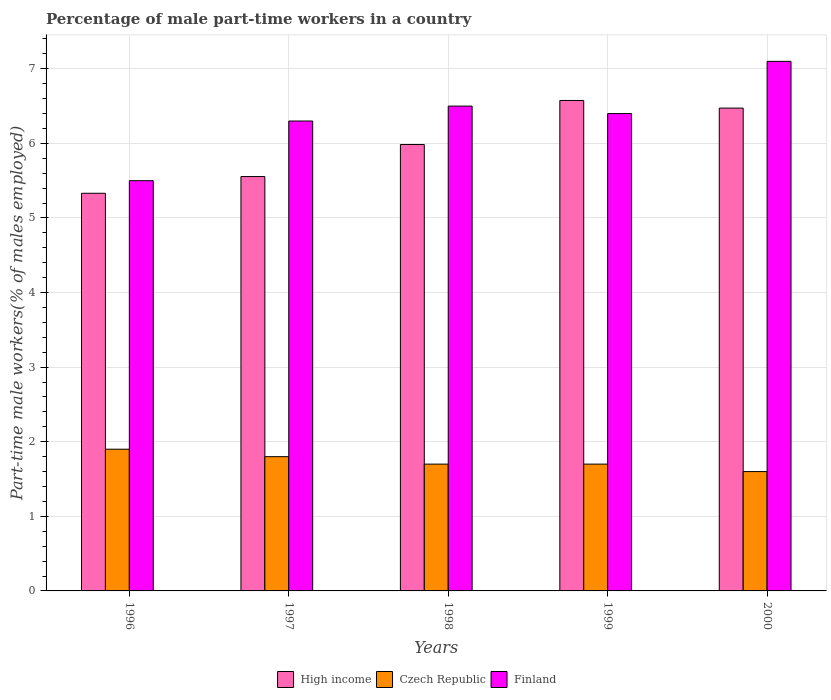Are the number of bars per tick equal to the number of legend labels?
Make the answer very short. Yes. Are the number of bars on each tick of the X-axis equal?
Your answer should be compact. Yes. How many bars are there on the 4th tick from the left?
Provide a succinct answer. 3. How many bars are there on the 5th tick from the right?
Give a very brief answer. 3. What is the label of the 1st group of bars from the left?
Your answer should be very brief. 1996. Across all years, what is the maximum percentage of male part-time workers in High income?
Offer a very short reply. 6.58. Across all years, what is the minimum percentage of male part-time workers in Czech Republic?
Provide a succinct answer. 1.6. In which year was the percentage of male part-time workers in Czech Republic minimum?
Keep it short and to the point. 2000. What is the total percentage of male part-time workers in Czech Republic in the graph?
Provide a short and direct response. 8.7. What is the difference between the percentage of male part-time workers in High income in 1998 and that in 1999?
Offer a terse response. -0.59. What is the difference between the percentage of male part-time workers in High income in 2000 and the percentage of male part-time workers in Finland in 1996?
Ensure brevity in your answer.  0.97. What is the average percentage of male part-time workers in Czech Republic per year?
Ensure brevity in your answer.  1.74. In the year 1996, what is the difference between the percentage of male part-time workers in Czech Republic and percentage of male part-time workers in Finland?
Provide a short and direct response. -3.6. What is the ratio of the percentage of male part-time workers in High income in 1998 to that in 2000?
Provide a short and direct response. 0.92. Is the percentage of male part-time workers in Czech Republic in 1996 less than that in 1997?
Your response must be concise. No. Is the difference between the percentage of male part-time workers in Czech Republic in 1997 and 1999 greater than the difference between the percentage of male part-time workers in Finland in 1997 and 1999?
Your answer should be very brief. Yes. What is the difference between the highest and the second highest percentage of male part-time workers in Czech Republic?
Provide a short and direct response. 0.1. What is the difference between the highest and the lowest percentage of male part-time workers in Czech Republic?
Ensure brevity in your answer.  0.3. In how many years, is the percentage of male part-time workers in Czech Republic greater than the average percentage of male part-time workers in Czech Republic taken over all years?
Provide a succinct answer. 2. Is the sum of the percentage of male part-time workers in High income in 1998 and 2000 greater than the maximum percentage of male part-time workers in Czech Republic across all years?
Give a very brief answer. Yes. What does the 2nd bar from the right in 2000 represents?
Make the answer very short. Czech Republic. How many bars are there?
Provide a short and direct response. 15. Are the values on the major ticks of Y-axis written in scientific E-notation?
Ensure brevity in your answer.  No. Where does the legend appear in the graph?
Offer a terse response. Bottom center. How many legend labels are there?
Your answer should be compact. 3. How are the legend labels stacked?
Make the answer very short. Horizontal. What is the title of the graph?
Your answer should be very brief. Percentage of male part-time workers in a country. What is the label or title of the X-axis?
Your response must be concise. Years. What is the label or title of the Y-axis?
Your answer should be compact. Part-time male workers(% of males employed). What is the Part-time male workers(% of males employed) of High income in 1996?
Provide a short and direct response. 5.33. What is the Part-time male workers(% of males employed) of Czech Republic in 1996?
Ensure brevity in your answer.  1.9. What is the Part-time male workers(% of males employed) of High income in 1997?
Give a very brief answer. 5.56. What is the Part-time male workers(% of males employed) of Czech Republic in 1997?
Offer a terse response. 1.8. What is the Part-time male workers(% of males employed) in Finland in 1997?
Make the answer very short. 6.3. What is the Part-time male workers(% of males employed) in High income in 1998?
Provide a succinct answer. 5.98. What is the Part-time male workers(% of males employed) in Czech Republic in 1998?
Give a very brief answer. 1.7. What is the Part-time male workers(% of males employed) in Finland in 1998?
Your answer should be very brief. 6.5. What is the Part-time male workers(% of males employed) of High income in 1999?
Offer a very short reply. 6.58. What is the Part-time male workers(% of males employed) of Czech Republic in 1999?
Ensure brevity in your answer.  1.7. What is the Part-time male workers(% of males employed) of Finland in 1999?
Offer a very short reply. 6.4. What is the Part-time male workers(% of males employed) of High income in 2000?
Provide a succinct answer. 6.47. What is the Part-time male workers(% of males employed) of Czech Republic in 2000?
Give a very brief answer. 1.6. What is the Part-time male workers(% of males employed) of Finland in 2000?
Ensure brevity in your answer.  7.1. Across all years, what is the maximum Part-time male workers(% of males employed) in High income?
Ensure brevity in your answer.  6.58. Across all years, what is the maximum Part-time male workers(% of males employed) of Czech Republic?
Your answer should be compact. 1.9. Across all years, what is the maximum Part-time male workers(% of males employed) in Finland?
Keep it short and to the point. 7.1. Across all years, what is the minimum Part-time male workers(% of males employed) in High income?
Your response must be concise. 5.33. Across all years, what is the minimum Part-time male workers(% of males employed) of Czech Republic?
Provide a short and direct response. 1.6. What is the total Part-time male workers(% of males employed) in High income in the graph?
Ensure brevity in your answer.  29.92. What is the total Part-time male workers(% of males employed) of Finland in the graph?
Ensure brevity in your answer.  31.8. What is the difference between the Part-time male workers(% of males employed) of High income in 1996 and that in 1997?
Your answer should be compact. -0.22. What is the difference between the Part-time male workers(% of males employed) in Finland in 1996 and that in 1997?
Make the answer very short. -0.8. What is the difference between the Part-time male workers(% of males employed) of High income in 1996 and that in 1998?
Your response must be concise. -0.65. What is the difference between the Part-time male workers(% of males employed) of High income in 1996 and that in 1999?
Provide a succinct answer. -1.24. What is the difference between the Part-time male workers(% of males employed) in High income in 1996 and that in 2000?
Provide a short and direct response. -1.14. What is the difference between the Part-time male workers(% of males employed) in Czech Republic in 1996 and that in 2000?
Give a very brief answer. 0.3. What is the difference between the Part-time male workers(% of males employed) of High income in 1997 and that in 1998?
Make the answer very short. -0.43. What is the difference between the Part-time male workers(% of males employed) in Czech Republic in 1997 and that in 1998?
Offer a terse response. 0.1. What is the difference between the Part-time male workers(% of males employed) of Finland in 1997 and that in 1998?
Your answer should be very brief. -0.2. What is the difference between the Part-time male workers(% of males employed) in High income in 1997 and that in 1999?
Keep it short and to the point. -1.02. What is the difference between the Part-time male workers(% of males employed) of Finland in 1997 and that in 1999?
Your response must be concise. -0.1. What is the difference between the Part-time male workers(% of males employed) in High income in 1997 and that in 2000?
Your answer should be compact. -0.92. What is the difference between the Part-time male workers(% of males employed) in Czech Republic in 1997 and that in 2000?
Your response must be concise. 0.2. What is the difference between the Part-time male workers(% of males employed) in Finland in 1997 and that in 2000?
Offer a very short reply. -0.8. What is the difference between the Part-time male workers(% of males employed) in High income in 1998 and that in 1999?
Your answer should be compact. -0.59. What is the difference between the Part-time male workers(% of males employed) in Czech Republic in 1998 and that in 1999?
Your response must be concise. 0. What is the difference between the Part-time male workers(% of males employed) in High income in 1998 and that in 2000?
Offer a very short reply. -0.49. What is the difference between the Part-time male workers(% of males employed) of Finland in 1998 and that in 2000?
Provide a succinct answer. -0.6. What is the difference between the Part-time male workers(% of males employed) in High income in 1999 and that in 2000?
Keep it short and to the point. 0.1. What is the difference between the Part-time male workers(% of males employed) in Czech Republic in 1999 and that in 2000?
Your answer should be very brief. 0.1. What is the difference between the Part-time male workers(% of males employed) in High income in 1996 and the Part-time male workers(% of males employed) in Czech Republic in 1997?
Provide a short and direct response. 3.53. What is the difference between the Part-time male workers(% of males employed) of High income in 1996 and the Part-time male workers(% of males employed) of Finland in 1997?
Ensure brevity in your answer.  -0.97. What is the difference between the Part-time male workers(% of males employed) in High income in 1996 and the Part-time male workers(% of males employed) in Czech Republic in 1998?
Offer a terse response. 3.63. What is the difference between the Part-time male workers(% of males employed) in High income in 1996 and the Part-time male workers(% of males employed) in Finland in 1998?
Give a very brief answer. -1.17. What is the difference between the Part-time male workers(% of males employed) in Czech Republic in 1996 and the Part-time male workers(% of males employed) in Finland in 1998?
Make the answer very short. -4.6. What is the difference between the Part-time male workers(% of males employed) in High income in 1996 and the Part-time male workers(% of males employed) in Czech Republic in 1999?
Make the answer very short. 3.63. What is the difference between the Part-time male workers(% of males employed) in High income in 1996 and the Part-time male workers(% of males employed) in Finland in 1999?
Your answer should be compact. -1.07. What is the difference between the Part-time male workers(% of males employed) in Czech Republic in 1996 and the Part-time male workers(% of males employed) in Finland in 1999?
Keep it short and to the point. -4.5. What is the difference between the Part-time male workers(% of males employed) of High income in 1996 and the Part-time male workers(% of males employed) of Czech Republic in 2000?
Provide a succinct answer. 3.73. What is the difference between the Part-time male workers(% of males employed) of High income in 1996 and the Part-time male workers(% of males employed) of Finland in 2000?
Keep it short and to the point. -1.77. What is the difference between the Part-time male workers(% of males employed) of Czech Republic in 1996 and the Part-time male workers(% of males employed) of Finland in 2000?
Make the answer very short. -5.2. What is the difference between the Part-time male workers(% of males employed) of High income in 1997 and the Part-time male workers(% of males employed) of Czech Republic in 1998?
Provide a short and direct response. 3.86. What is the difference between the Part-time male workers(% of males employed) of High income in 1997 and the Part-time male workers(% of males employed) of Finland in 1998?
Offer a terse response. -0.94. What is the difference between the Part-time male workers(% of males employed) of High income in 1997 and the Part-time male workers(% of males employed) of Czech Republic in 1999?
Your answer should be very brief. 3.86. What is the difference between the Part-time male workers(% of males employed) of High income in 1997 and the Part-time male workers(% of males employed) of Finland in 1999?
Offer a terse response. -0.84. What is the difference between the Part-time male workers(% of males employed) of High income in 1997 and the Part-time male workers(% of males employed) of Czech Republic in 2000?
Give a very brief answer. 3.96. What is the difference between the Part-time male workers(% of males employed) of High income in 1997 and the Part-time male workers(% of males employed) of Finland in 2000?
Offer a very short reply. -1.54. What is the difference between the Part-time male workers(% of males employed) in Czech Republic in 1997 and the Part-time male workers(% of males employed) in Finland in 2000?
Your answer should be very brief. -5.3. What is the difference between the Part-time male workers(% of males employed) of High income in 1998 and the Part-time male workers(% of males employed) of Czech Republic in 1999?
Provide a succinct answer. 4.28. What is the difference between the Part-time male workers(% of males employed) of High income in 1998 and the Part-time male workers(% of males employed) of Finland in 1999?
Provide a short and direct response. -0.42. What is the difference between the Part-time male workers(% of males employed) in Czech Republic in 1998 and the Part-time male workers(% of males employed) in Finland in 1999?
Your response must be concise. -4.7. What is the difference between the Part-time male workers(% of males employed) in High income in 1998 and the Part-time male workers(% of males employed) in Czech Republic in 2000?
Provide a short and direct response. 4.38. What is the difference between the Part-time male workers(% of males employed) of High income in 1998 and the Part-time male workers(% of males employed) of Finland in 2000?
Your response must be concise. -1.12. What is the difference between the Part-time male workers(% of males employed) in High income in 1999 and the Part-time male workers(% of males employed) in Czech Republic in 2000?
Your answer should be compact. 4.98. What is the difference between the Part-time male workers(% of males employed) of High income in 1999 and the Part-time male workers(% of males employed) of Finland in 2000?
Your response must be concise. -0.52. What is the average Part-time male workers(% of males employed) in High income per year?
Your answer should be very brief. 5.98. What is the average Part-time male workers(% of males employed) of Czech Republic per year?
Provide a succinct answer. 1.74. What is the average Part-time male workers(% of males employed) in Finland per year?
Give a very brief answer. 6.36. In the year 1996, what is the difference between the Part-time male workers(% of males employed) in High income and Part-time male workers(% of males employed) in Czech Republic?
Give a very brief answer. 3.43. In the year 1996, what is the difference between the Part-time male workers(% of males employed) in High income and Part-time male workers(% of males employed) in Finland?
Offer a terse response. -0.17. In the year 1996, what is the difference between the Part-time male workers(% of males employed) of Czech Republic and Part-time male workers(% of males employed) of Finland?
Ensure brevity in your answer.  -3.6. In the year 1997, what is the difference between the Part-time male workers(% of males employed) in High income and Part-time male workers(% of males employed) in Czech Republic?
Give a very brief answer. 3.76. In the year 1997, what is the difference between the Part-time male workers(% of males employed) of High income and Part-time male workers(% of males employed) of Finland?
Provide a short and direct response. -0.74. In the year 1997, what is the difference between the Part-time male workers(% of males employed) in Czech Republic and Part-time male workers(% of males employed) in Finland?
Ensure brevity in your answer.  -4.5. In the year 1998, what is the difference between the Part-time male workers(% of males employed) in High income and Part-time male workers(% of males employed) in Czech Republic?
Ensure brevity in your answer.  4.28. In the year 1998, what is the difference between the Part-time male workers(% of males employed) of High income and Part-time male workers(% of males employed) of Finland?
Offer a terse response. -0.52. In the year 1999, what is the difference between the Part-time male workers(% of males employed) of High income and Part-time male workers(% of males employed) of Czech Republic?
Your response must be concise. 4.88. In the year 1999, what is the difference between the Part-time male workers(% of males employed) of High income and Part-time male workers(% of males employed) of Finland?
Your response must be concise. 0.18. In the year 2000, what is the difference between the Part-time male workers(% of males employed) in High income and Part-time male workers(% of males employed) in Czech Republic?
Your answer should be compact. 4.87. In the year 2000, what is the difference between the Part-time male workers(% of males employed) of High income and Part-time male workers(% of males employed) of Finland?
Make the answer very short. -0.63. In the year 2000, what is the difference between the Part-time male workers(% of males employed) of Czech Republic and Part-time male workers(% of males employed) of Finland?
Your answer should be very brief. -5.5. What is the ratio of the Part-time male workers(% of males employed) of High income in 1996 to that in 1997?
Make the answer very short. 0.96. What is the ratio of the Part-time male workers(% of males employed) of Czech Republic in 1996 to that in 1997?
Provide a short and direct response. 1.06. What is the ratio of the Part-time male workers(% of males employed) in Finland in 1996 to that in 1997?
Your answer should be very brief. 0.87. What is the ratio of the Part-time male workers(% of males employed) in High income in 1996 to that in 1998?
Offer a terse response. 0.89. What is the ratio of the Part-time male workers(% of males employed) in Czech Republic in 1996 to that in 1998?
Offer a very short reply. 1.12. What is the ratio of the Part-time male workers(% of males employed) of Finland in 1996 to that in 1998?
Offer a very short reply. 0.85. What is the ratio of the Part-time male workers(% of males employed) of High income in 1996 to that in 1999?
Provide a succinct answer. 0.81. What is the ratio of the Part-time male workers(% of males employed) in Czech Republic in 1996 to that in 1999?
Keep it short and to the point. 1.12. What is the ratio of the Part-time male workers(% of males employed) in Finland in 1996 to that in 1999?
Provide a succinct answer. 0.86. What is the ratio of the Part-time male workers(% of males employed) in High income in 1996 to that in 2000?
Keep it short and to the point. 0.82. What is the ratio of the Part-time male workers(% of males employed) of Czech Republic in 1996 to that in 2000?
Offer a terse response. 1.19. What is the ratio of the Part-time male workers(% of males employed) of Finland in 1996 to that in 2000?
Your answer should be compact. 0.77. What is the ratio of the Part-time male workers(% of males employed) of High income in 1997 to that in 1998?
Give a very brief answer. 0.93. What is the ratio of the Part-time male workers(% of males employed) in Czech Republic in 1997 to that in 1998?
Offer a very short reply. 1.06. What is the ratio of the Part-time male workers(% of males employed) of Finland in 1997 to that in 1998?
Your answer should be very brief. 0.97. What is the ratio of the Part-time male workers(% of males employed) of High income in 1997 to that in 1999?
Offer a very short reply. 0.84. What is the ratio of the Part-time male workers(% of males employed) of Czech Republic in 1997 to that in 1999?
Give a very brief answer. 1.06. What is the ratio of the Part-time male workers(% of males employed) of Finland in 1997 to that in 1999?
Ensure brevity in your answer.  0.98. What is the ratio of the Part-time male workers(% of males employed) of High income in 1997 to that in 2000?
Your answer should be compact. 0.86. What is the ratio of the Part-time male workers(% of males employed) in Finland in 1997 to that in 2000?
Provide a succinct answer. 0.89. What is the ratio of the Part-time male workers(% of males employed) of High income in 1998 to that in 1999?
Keep it short and to the point. 0.91. What is the ratio of the Part-time male workers(% of males employed) of Finland in 1998 to that in 1999?
Your answer should be compact. 1.02. What is the ratio of the Part-time male workers(% of males employed) in High income in 1998 to that in 2000?
Your answer should be very brief. 0.92. What is the ratio of the Part-time male workers(% of males employed) of Czech Republic in 1998 to that in 2000?
Your response must be concise. 1.06. What is the ratio of the Part-time male workers(% of males employed) of Finland in 1998 to that in 2000?
Offer a very short reply. 0.92. What is the ratio of the Part-time male workers(% of males employed) of High income in 1999 to that in 2000?
Offer a terse response. 1.02. What is the ratio of the Part-time male workers(% of males employed) of Finland in 1999 to that in 2000?
Make the answer very short. 0.9. What is the difference between the highest and the second highest Part-time male workers(% of males employed) of High income?
Your response must be concise. 0.1. What is the difference between the highest and the lowest Part-time male workers(% of males employed) in High income?
Your answer should be compact. 1.24. 